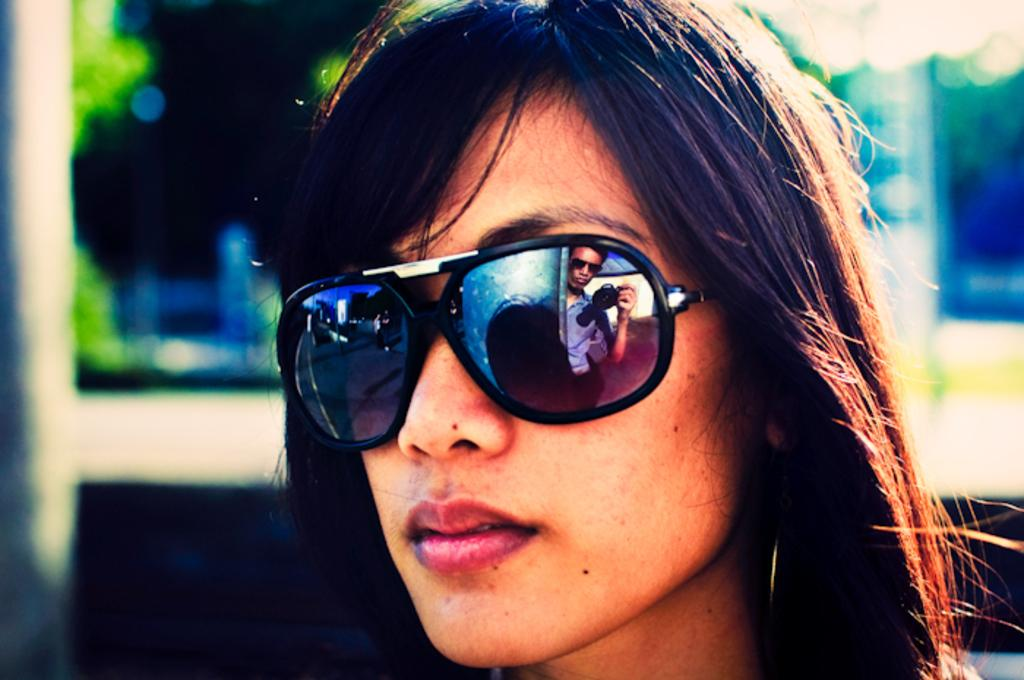Who is present in the image? There is a woman in the image. What is the woman wearing on her face? The woman is wearing sunglasses. What feature do the sunglasses have? The sunglasses have a mirror image of a person. Can you describe the background of the image? The background of the image is blurred. What type of plastic material can be seen in the cemetery in the image? There is no cemetery or plastic material present in the image. 